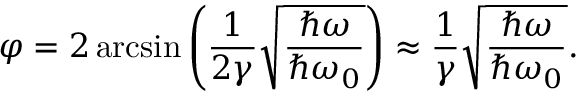Convert formula to latex. <formula><loc_0><loc_0><loc_500><loc_500>\varphi = 2 \arcsin \left ( \frac { 1 } { 2 \gamma } \sqrt { \frac { \hbar { \omega } } { \hbar { \omega } _ { 0 } } } \right ) \approx \frac { 1 } { \gamma } \sqrt { \frac { \hbar { \omega } } { \hbar { \omega } _ { 0 } } } .</formula> 